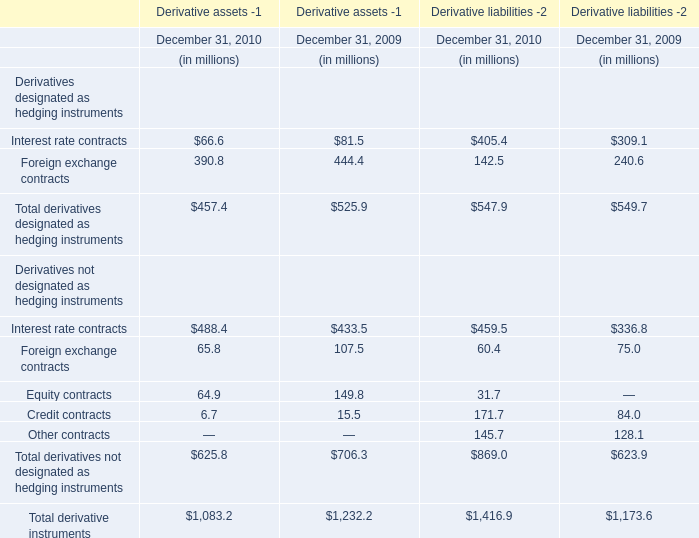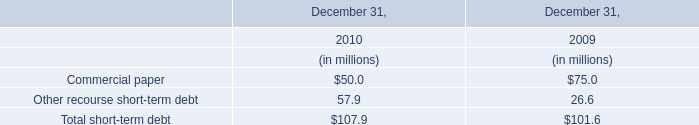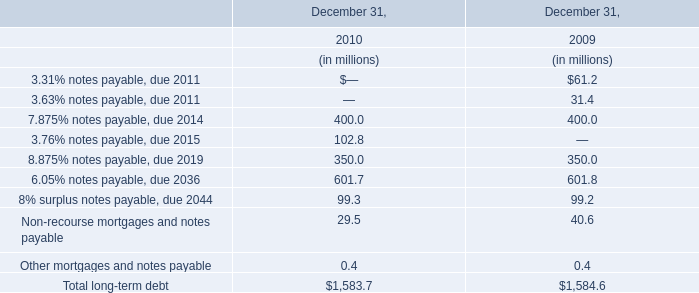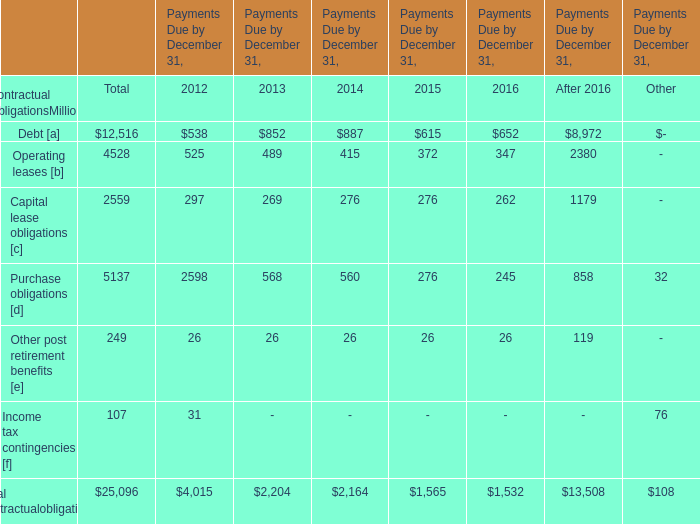assuming a 120 day inventory turn , how of the receivables balance at december 31 , 2010 , was collected in q1 2011 in billions? 
Computations: (16.3 / 3)
Answer: 5.43333. 